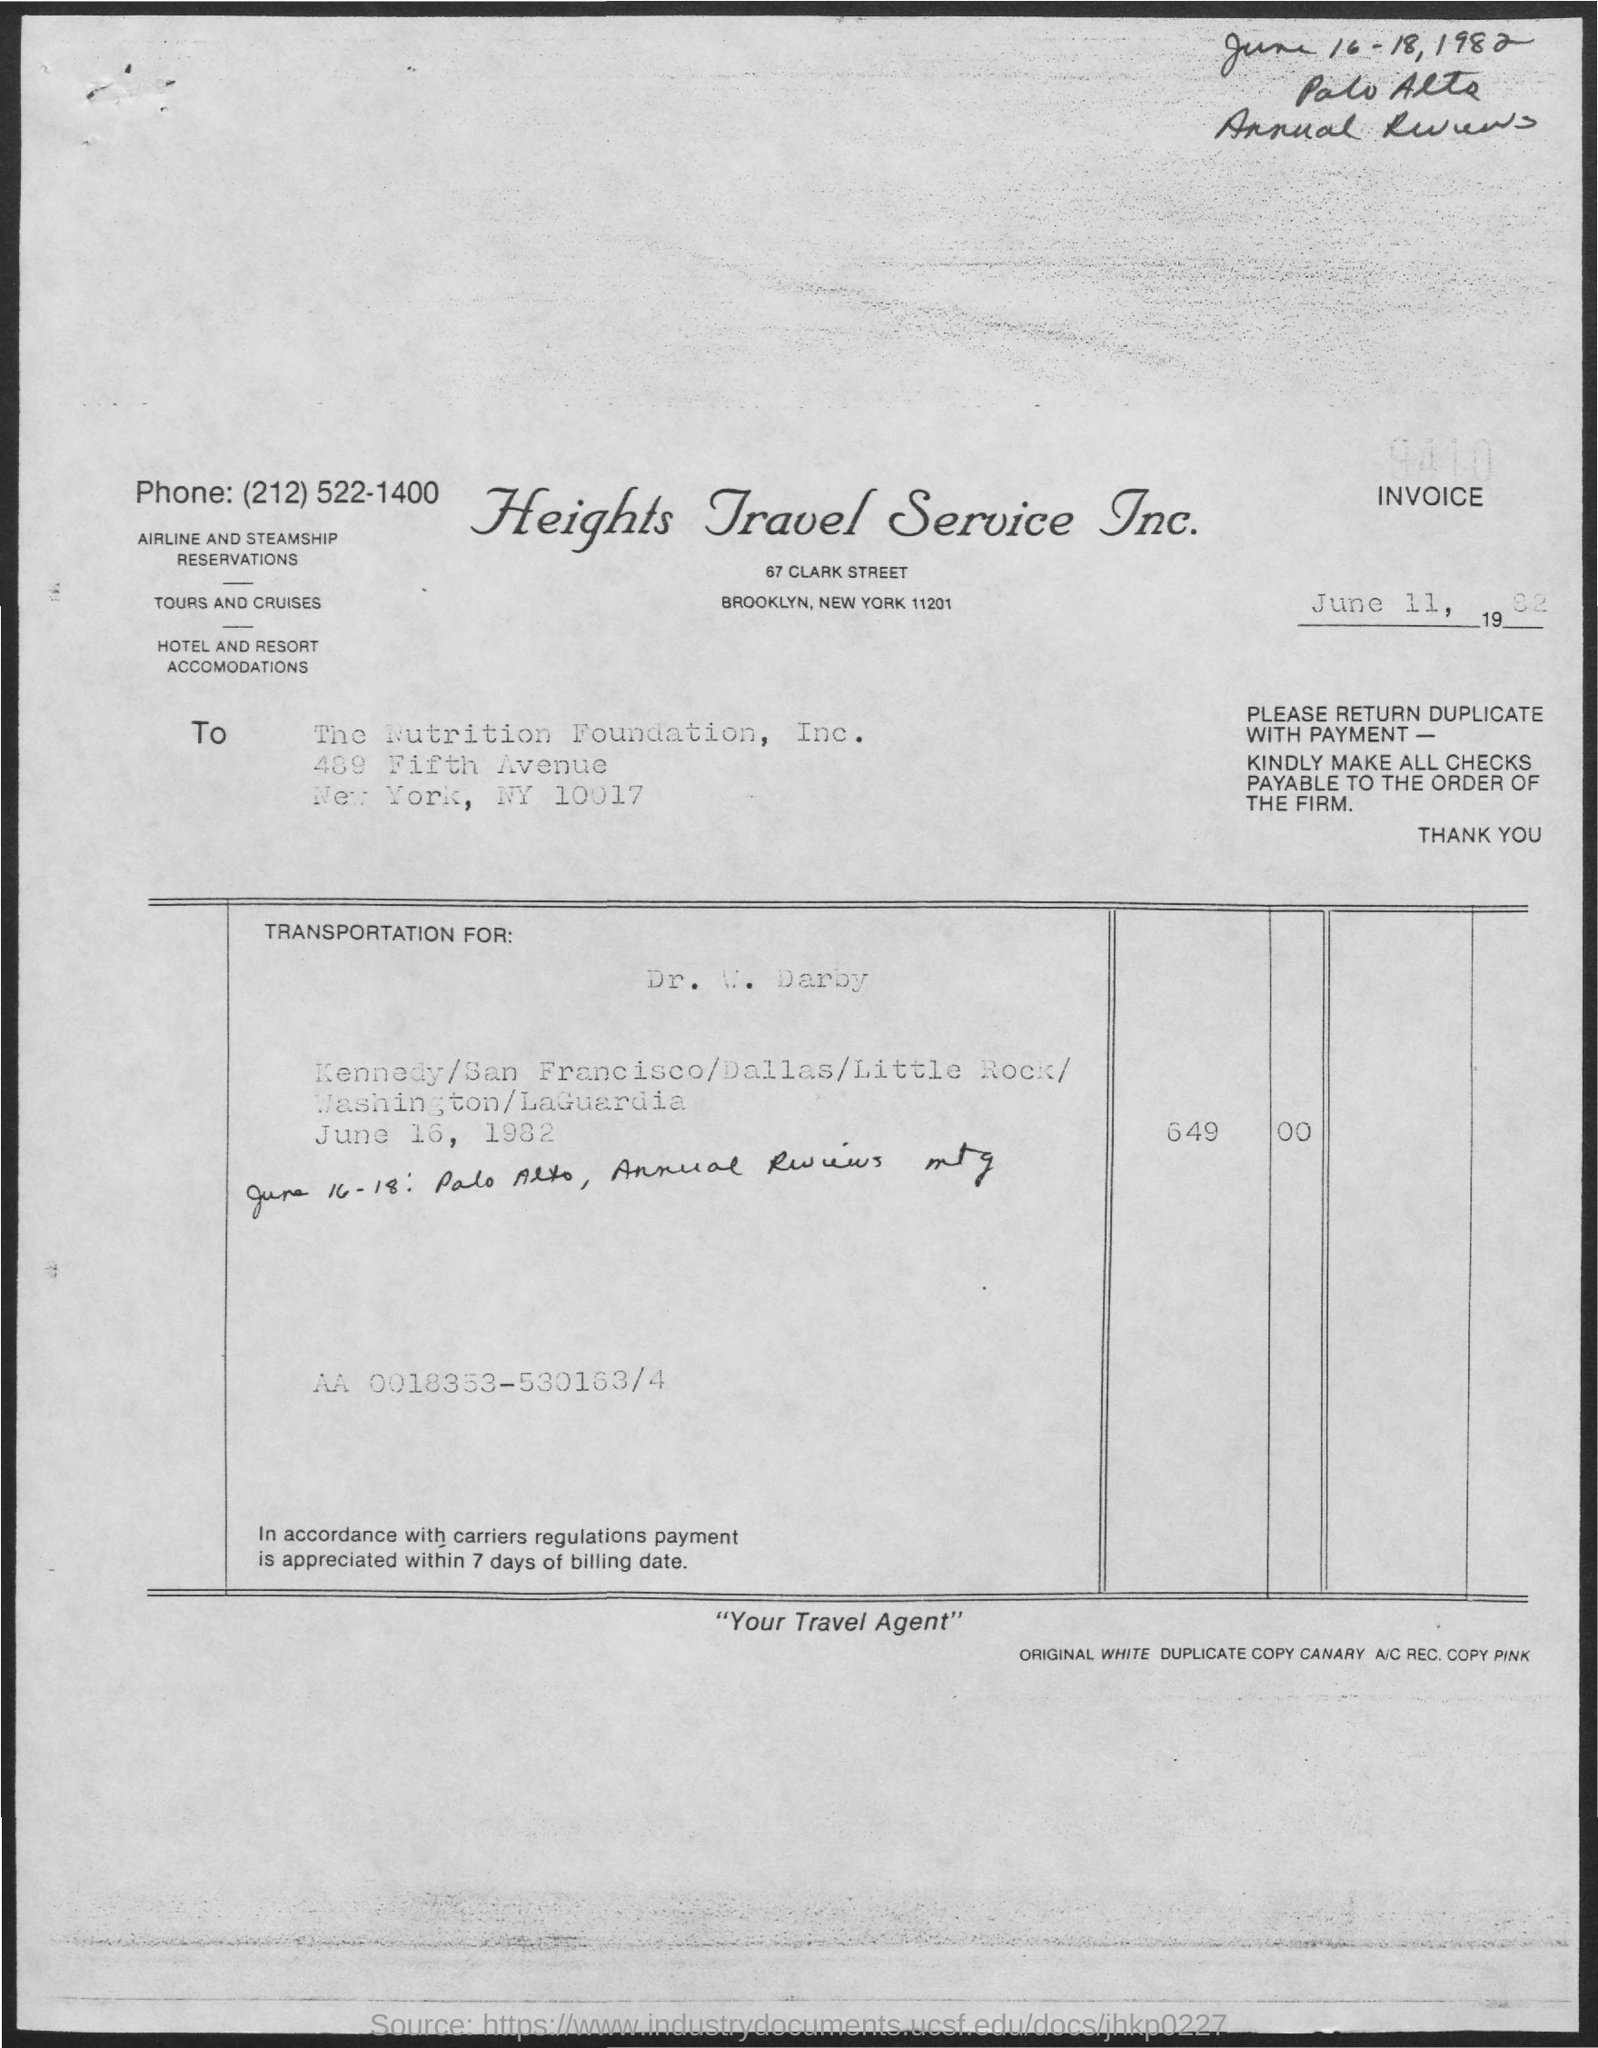Whats the date invoice is dated on?
Offer a terse response. June 11, 1982. 